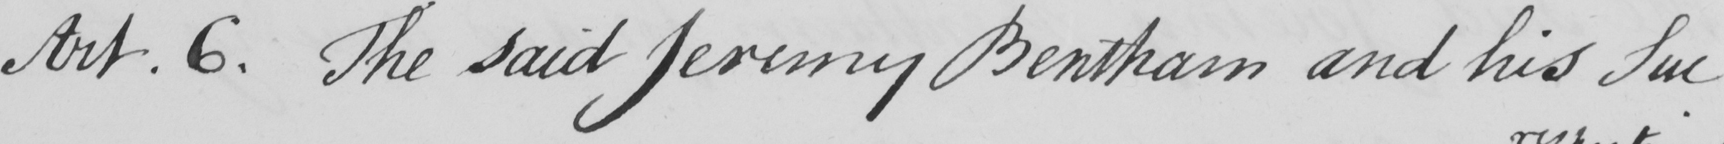Can you read and transcribe this handwriting? Art.6 . The said Jeremy Bentham and his Suc- 